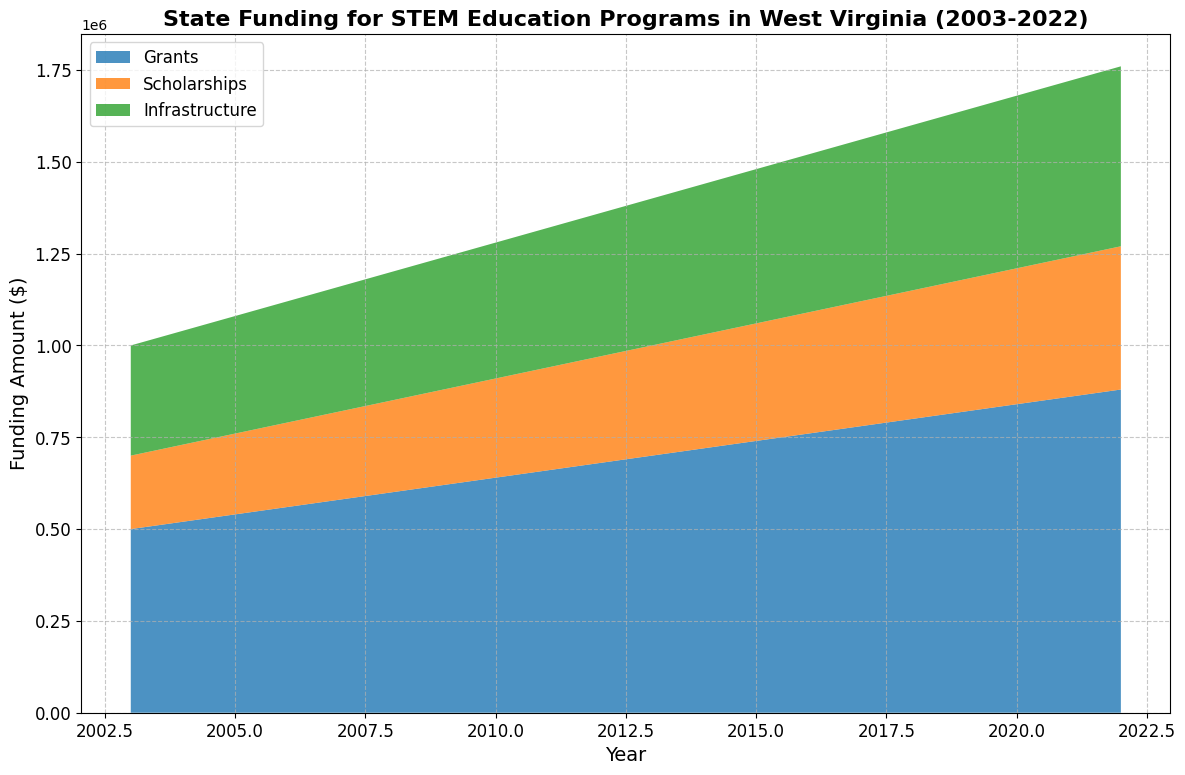What year did grants first reach $800,000? The grants funding reaches $800,000 in the year 2018, as shown by the figure.
Answer: 2018 Which category of funding grew the fastest from 2003 to 2022? By comparing growth rates, the grants funding increased from $500,000 in 2003 to $880,000 in 2022, infrastructure funding increased from $300,000 to $490,000, and scholarships increased from $200,000 to $390,000. The grants category saw the highest increase, growing by $380,000.
Answer: Grants What is the total amount of funding in the year 2010? Sum the funding for grants, scholarships, and infrastructure in 2010: $640,000 (grants) + $270,000 (scholarships) + $370,000 (infrastructure) resulting in $1,280,000 total.
Answer: $1,280,000 In which year did scholarships surpass $300,000 for the first time? Looking at the area chart, scholarships funding first surpasses $300,000 in 2013.
Answer: 2013 Compare the growth in infrastructure funding from 2010 to 2020. Infrastructure funding in 2010 was $370,000 and increased to $470,000 in 2020. The total growth over this period is $100,000.
Answer: $100,000 What was the total funding for all categories in 2022? Summing up all funding categories for 2022: $880,000 (grants) + $390,000 (scholarships) + $490,000 (infrastructure) equals $1,760,000.
Answer: $1,760,000 Which year showed an equal contribution of grants and infrastructure funding? By observing the chart, note that no single year showed equal contributions between grants and infrastructure; grants always funded more than infrastructure.
Answer: Never What is the average amount of scholarships funding over these 20 years? Calculate the sum of scholarships amount over 20 years and divide by 20: ($200,000 + $210,000 + $220,000 + $230,000 + $240,000 + $250,000 + $260,000 + $270,000 + $280,000 + $290,000 + $300,000 + $310,000 + $320,000 + $330,000 + $340,000 + $350,000 + $360,000 + $370,000 + $380,000 + $390,000) / 20 resulting in $330,000.
Answer: $305,000 In which year did total funding for STEM education programs reach $1.5 million for the first time? Summing up funding from grants, scholarships, and infrastructure for each year, total funding first hits $1.5 million in 2018: $800,000 (grants) + $350,000 (scholarships) + $450,000 (infrastructure).
Answer: 2018 Between which years did the funding for scholarships and infrastructure show the same percentage increase? Both scholarships and infrastructure increased by 50% from 2003 to 2022. Scholarships rose from $200,000 to $390,000, and infrastructure from $300,000 to $490,000.
Answer: 2003 to 2022 